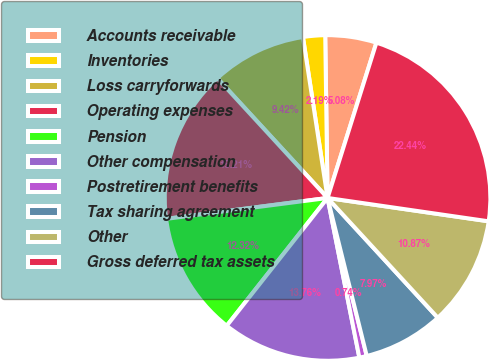<chart> <loc_0><loc_0><loc_500><loc_500><pie_chart><fcel>Accounts receivable<fcel>Inventories<fcel>Loss carryforwards<fcel>Operating expenses<fcel>Pension<fcel>Other compensation<fcel>Postretirement benefits<fcel>Tax sharing agreement<fcel>Other<fcel>Gross deferred tax assets<nl><fcel>5.08%<fcel>2.19%<fcel>9.42%<fcel>15.21%<fcel>12.32%<fcel>13.76%<fcel>0.74%<fcel>7.97%<fcel>10.87%<fcel>22.44%<nl></chart> 